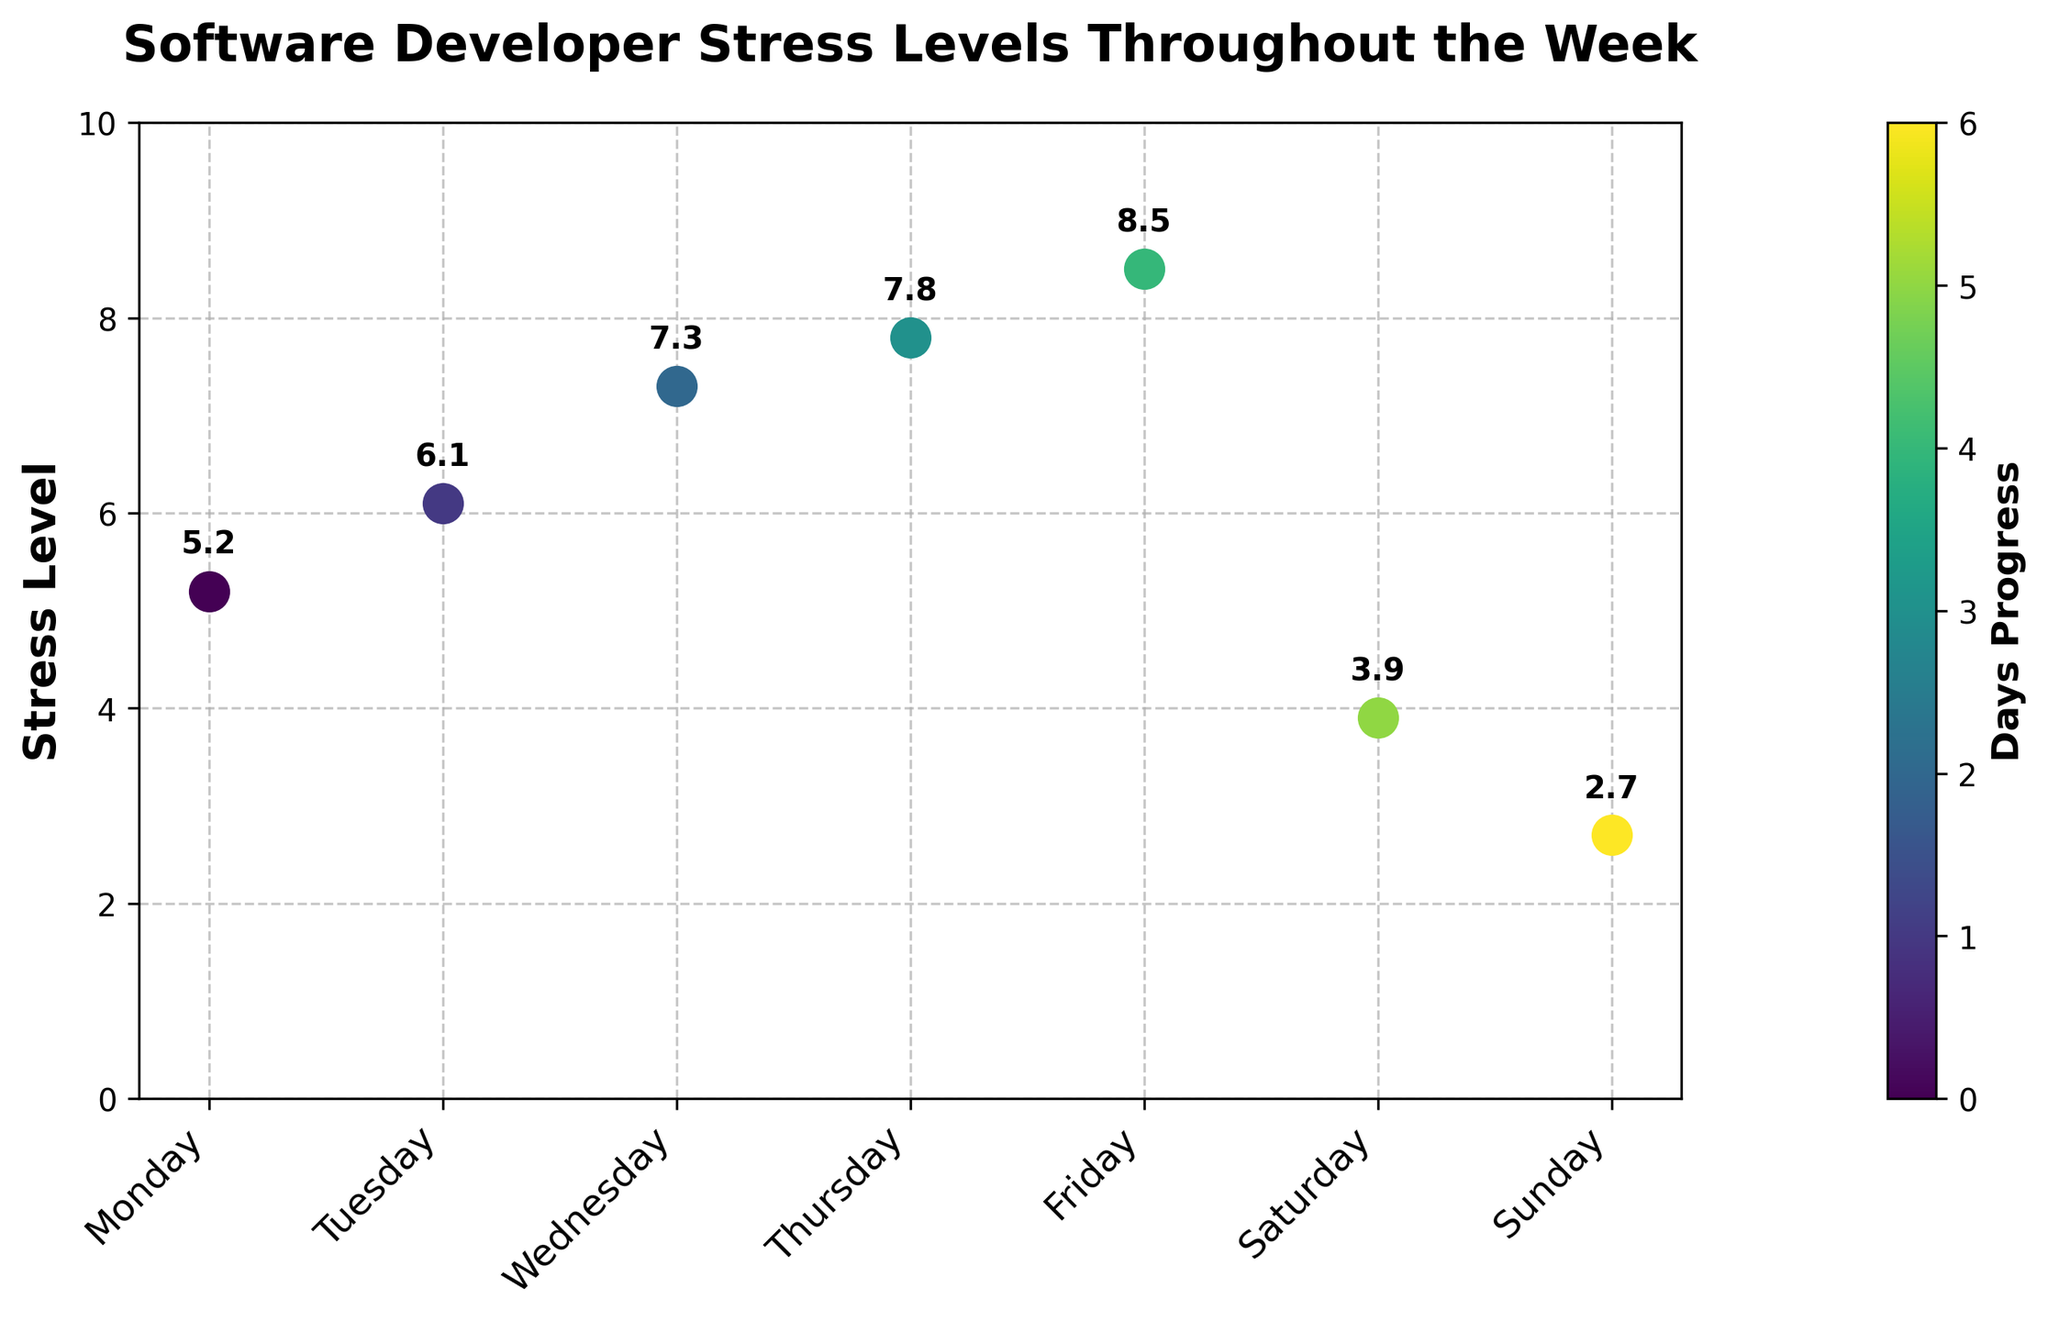How does the stress level on Wednesday compare to Monday? The figure shows the stress level is 7.3 on Wednesday and 5.2 on Monday. Comparing these, Wednesday's stress level is higher by 2.1 points.
Answer: Wednesday's stress level is higher by 2.1 points Which day has the lowest reported stress level? By looking at the figure, the stress level on Sunday is the lowest at 2.7.
Answer: Sunday What is the average stress level from Monday to Friday? Adding the stress levels from Monday to Friday: 5.2 + 6.1 + 7.3 + 7.8 + 8.5 = 34.9. Dividing by 5 gives 34.9 / 5 = 6.98.
Answer: 6.98 What is the difference in stress levels between Friday and Saturday? The stress level on Friday is 8.5 and on Saturday is 3.9. The difference is 8.5 - 3.9 = 4.6.
Answer: 4.6 Between which two consecutive days is the largest increase in stress levels observed? From the figure, the stress increases by 1.2 points from Tuesday (6.1) to Wednesday (7.3), which is the largest increase among all consecutive days.
Answer: Tuesday to Wednesday How does the stress level trend change from Friday to Sunday? After reaching a peak of 8.5 on Friday, the stress levels drop to 3.9 on Saturday and further decrease to 2.7 on Sunday, showing a clear downward trend.
Answer: It decreases What is the stress level on Thursday and how does it compare with the overall week’s trend? On Thursday, the stress level is 7.8. This is part of an increasing trend from Monday to Friday, before it drops on the weekend.
Answer: Increases to 7.8 as part of an upward trend How much does the stress level drop from its highest to its lowest point during the week? The highest stress level is 8.5 on Friday, and the lowest is 2.7 on Sunday. The drop is 8.5 - 2.7 = 5.8.
Answer: 5.8 What can be said about the stress levels on the weekend compared to the weekdays? The stress levels on the weekend (Saturday 3.9, Sunday 2.7) are significantly lower compared to any of the weekdays, where it ranges from 5.2 to 8.5.
Answer: Weekend stress levels are lower How does the change in stress levels from Tuesday to Friday compare to the change from Friday to Sunday? From Tuesday (6.1) to Friday (8.5), stress levels increase by 2.4 points. From Friday (8.5) to Sunday (2.7), they decrease by 5.8 points. Comparatively, the change from Friday to Sunday is much larger.
Answer: Larger change from Friday to Sunday 